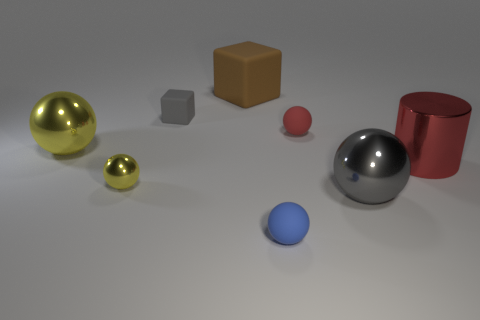What is the size of the gray ball that is made of the same material as the cylinder?
Keep it short and to the point. Large. Does the small yellow object have the same material as the brown block?
Make the answer very short. No. There is a large brown object that is the same material as the small blue sphere; what is its shape?
Offer a very short reply. Cube. How many other objects are the same shape as the red rubber object?
Your answer should be compact. 4. Does the shiny ball on the right side of the brown rubber object have the same size as the large brown cube?
Your answer should be very brief. Yes. Is the number of tiny rubber things that are left of the brown thing greater than the number of tiny purple rubber cylinders?
Provide a short and direct response. Yes. There is a tiny matte object right of the blue matte thing; how many red things are left of it?
Provide a short and direct response. 0. Are there fewer big brown objects left of the small gray matte thing than small brown metallic spheres?
Make the answer very short. No. There is a tiny matte thing in front of the large ball that is in front of the large yellow object; is there a brown block that is in front of it?
Ensure brevity in your answer.  No. Is the material of the tiny blue object the same as the big yellow ball that is to the left of the small shiny thing?
Your answer should be compact. No. 